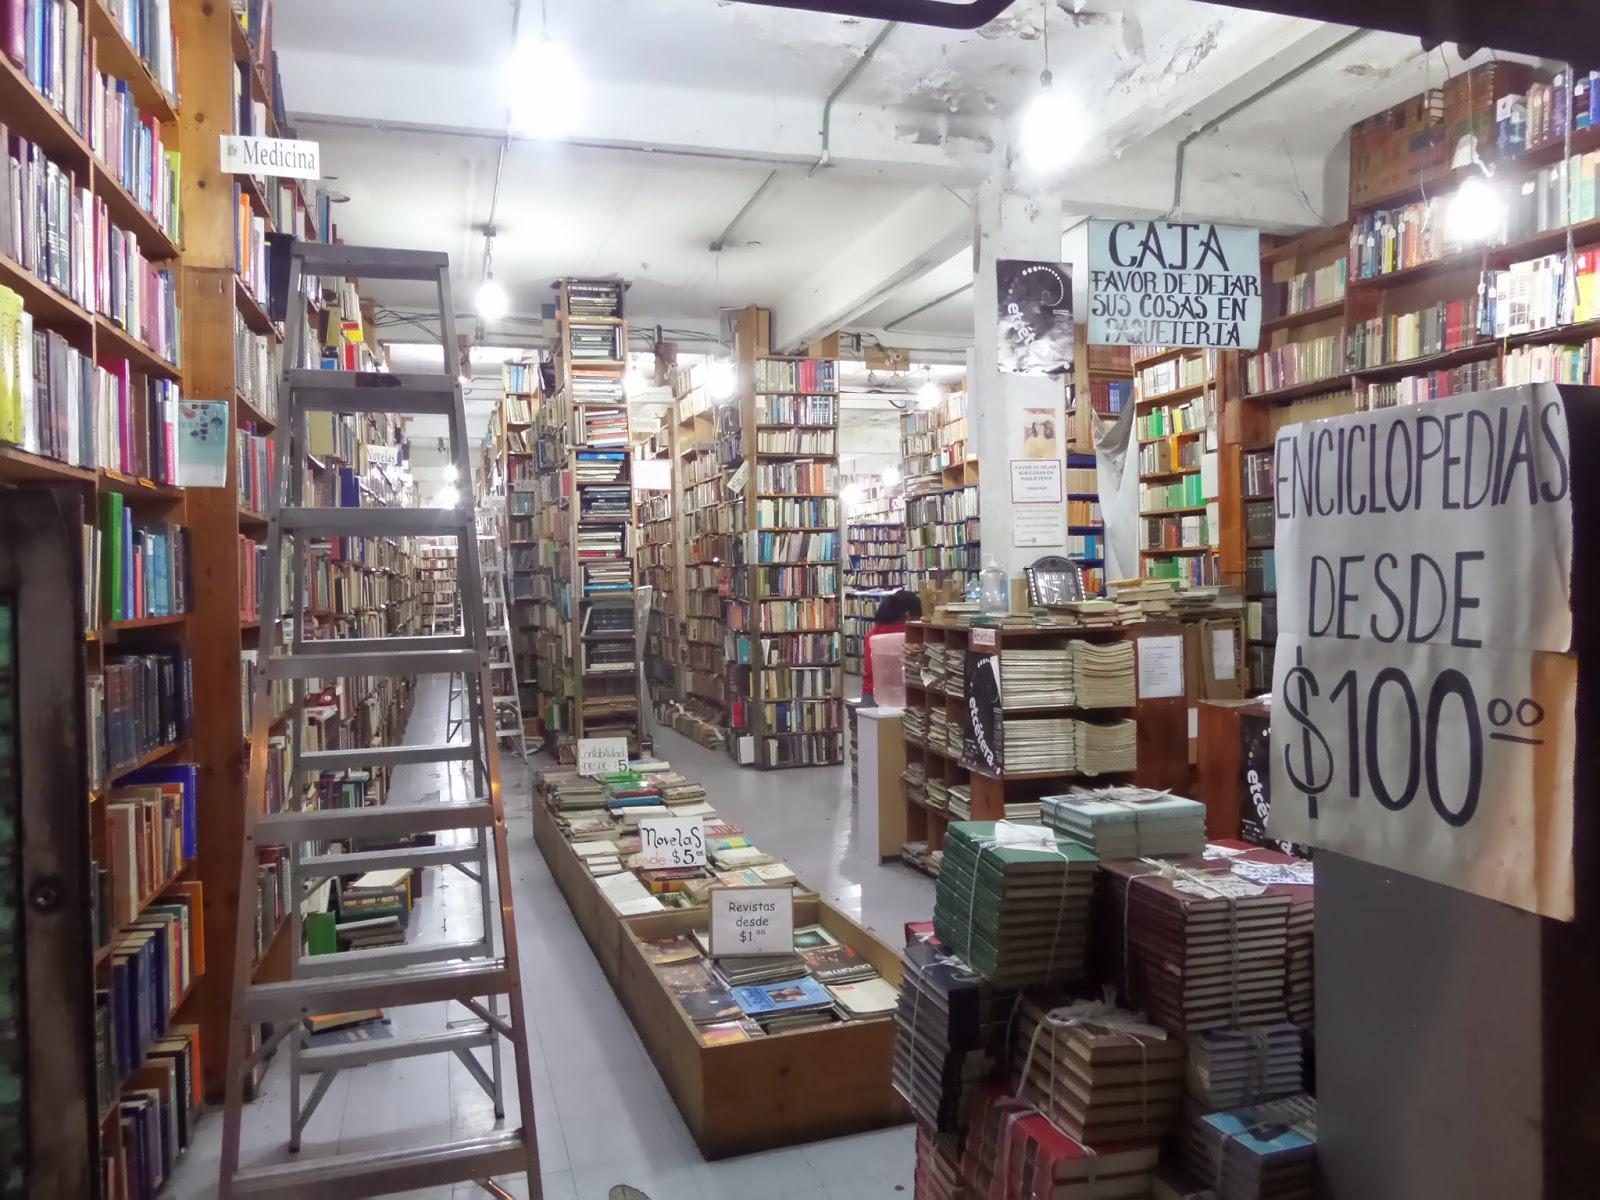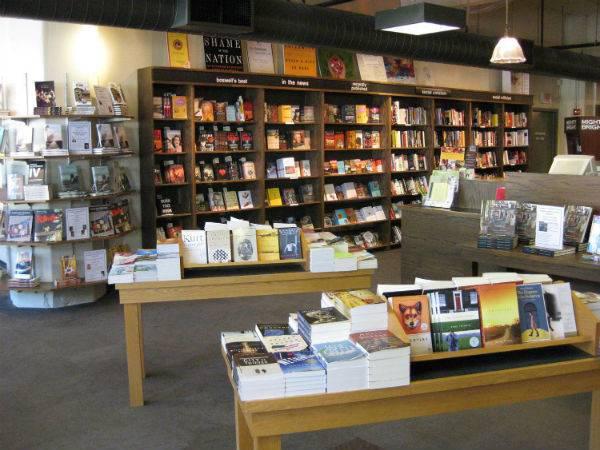The first image is the image on the left, the second image is the image on the right. For the images displayed, is the sentence "There are three people in a bookstore." factually correct? Answer yes or no. No. The first image is the image on the left, the second image is the image on the right. Assess this claim about the two images: "There are multiple people in a shop in the right image.". Correct or not? Answer yes or no. No. 